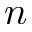Convert formula to latex. <formula><loc_0><loc_0><loc_500><loc_500>n</formula> 